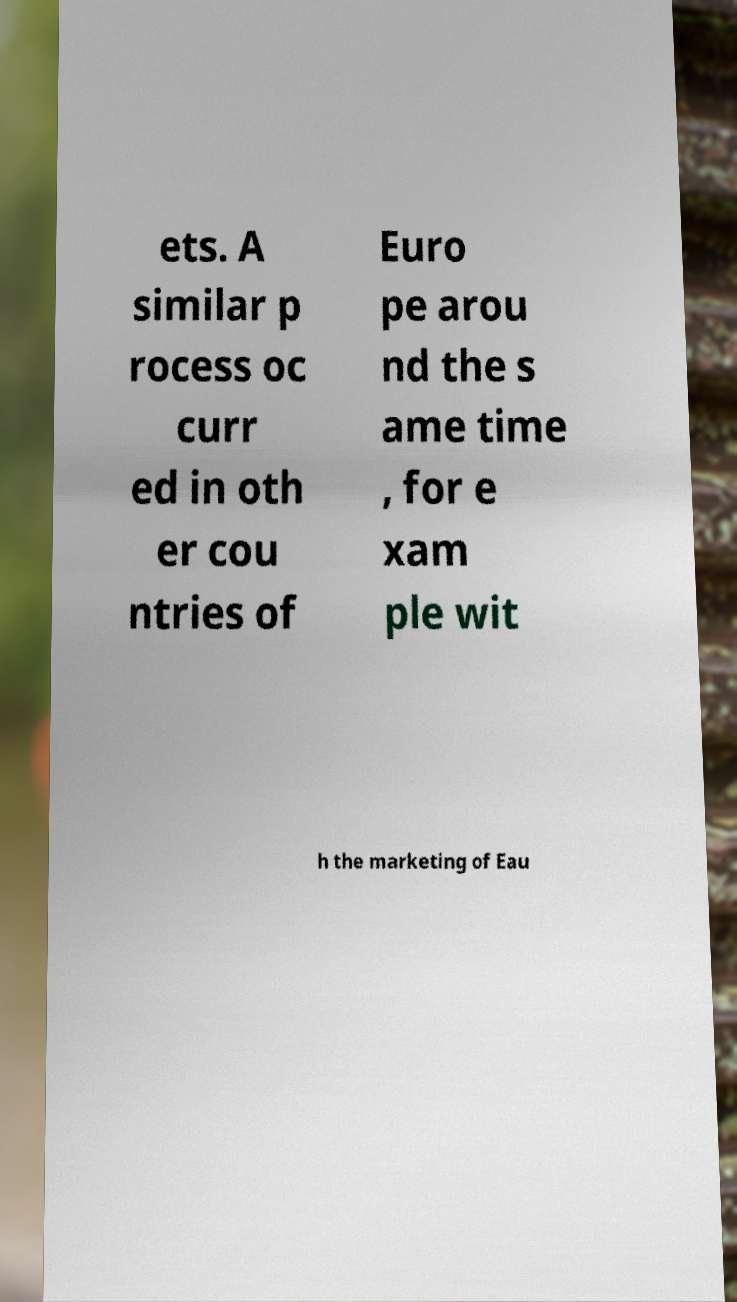What messages or text are displayed in this image? I need them in a readable, typed format. ets. A similar p rocess oc curr ed in oth er cou ntries of Euro pe arou nd the s ame time , for e xam ple wit h the marketing of Eau 